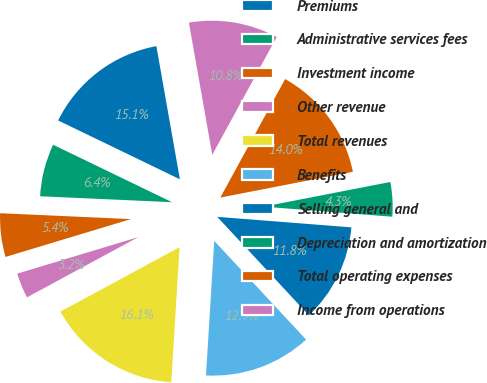<chart> <loc_0><loc_0><loc_500><loc_500><pie_chart><fcel>Premiums<fcel>Administrative services fees<fcel>Investment income<fcel>Other revenue<fcel>Total revenues<fcel>Benefits<fcel>Selling general and<fcel>Depreciation and amortization<fcel>Total operating expenses<fcel>Income from operations<nl><fcel>15.05%<fcel>6.45%<fcel>5.38%<fcel>3.23%<fcel>16.13%<fcel>12.9%<fcel>11.83%<fcel>4.3%<fcel>13.98%<fcel>10.75%<nl></chart> 